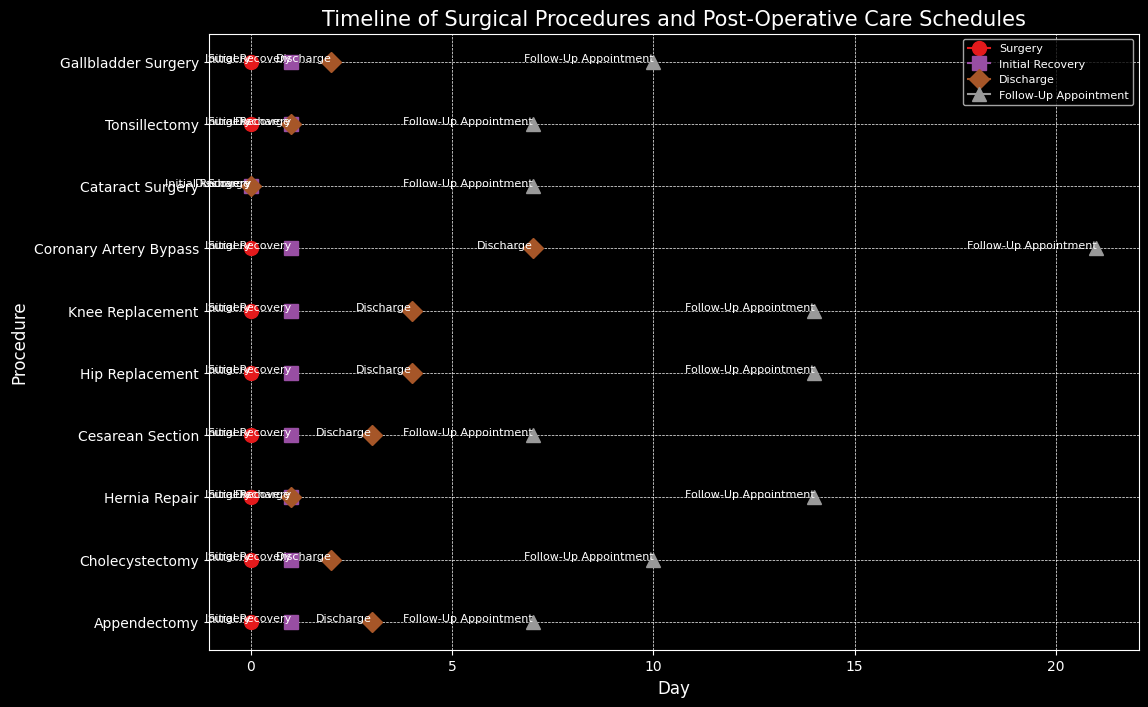What is the time difference between surgery and discharge for Coronary Artery Bypass patients? To find the time difference, look at the position of "Surgery" and "Discharge" events for the Coronary Artery Bypass procedure on the timeline. "Surgery" is on day 0, and "Discharge" is on day 7, thus the time difference is 7 days.
Answer: 7 days Which procedure has the shortest initial recovery period? Check the timeline for the "Initial Recovery" event for all procedures. Cataract Surgery has an "Initial Recovery" right on day 0, which is the shortest.
Answer: Cataract Surgery Among Appendectomy, Cholecystectomy, and Hernia Repair, which has the earliest follow-up appointment? Compare the "Follow-Up Appointment" days for Appendectomy (day 7), Cholecystectomy (day 10), and Hernia Repair (day 14) procedures. Appendectomy has the earliest follow-up appointment on day 7.
Answer: Appendectomy Which procedures have their discharge days later than 3 days after surgery? Look at the "Discharge" event days for all procedures. Hip Replacement, Knee Replacement, and Coronary Artery Bypass have discharge days 4 and 7 days after surgery, which are all later than 3 days.
Answer: Hip Replacement, Knee Replacement, Coronary Artery Bypass How many days after surgery is the follow-up appointment scheduled for Tonsillectomy? Identify the "Follow-Up Appointment" event for Tonsillectomy on the timeline. It is scheduled 7 days after the surgery.
Answer: 7 days Which event is marked with a triangle in the figure? Observe the markers used for different events in the figure. The triangle marker corresponds to the "Follow-Up Appointment" event.
Answer: Follow-Up Appointment Are any procedures discharged on the same day as the initial recovery? If yes, which one(s)? Check if any procedures have their "Discharge" event on the same day as their "Initial Recovery" event. Hernia Repair and Tonsillectomy both have their "Discharge" on the same day as "Initial Recovery" (Day 1).
Answer: Hernia Repair, Tonsillectomy What is the average time from surgery to follow-up appointment across all procedures? Add up the days from "Surgery" to "Follow-Up Appointment" for each procedure and divide by the total number of procedures: (7 + 10 + 14 + 7 + 14 + 14 + 21 + 7 + 7 + 10)/10 = 111/10 = 11.1.
Answer: 11.1 days 